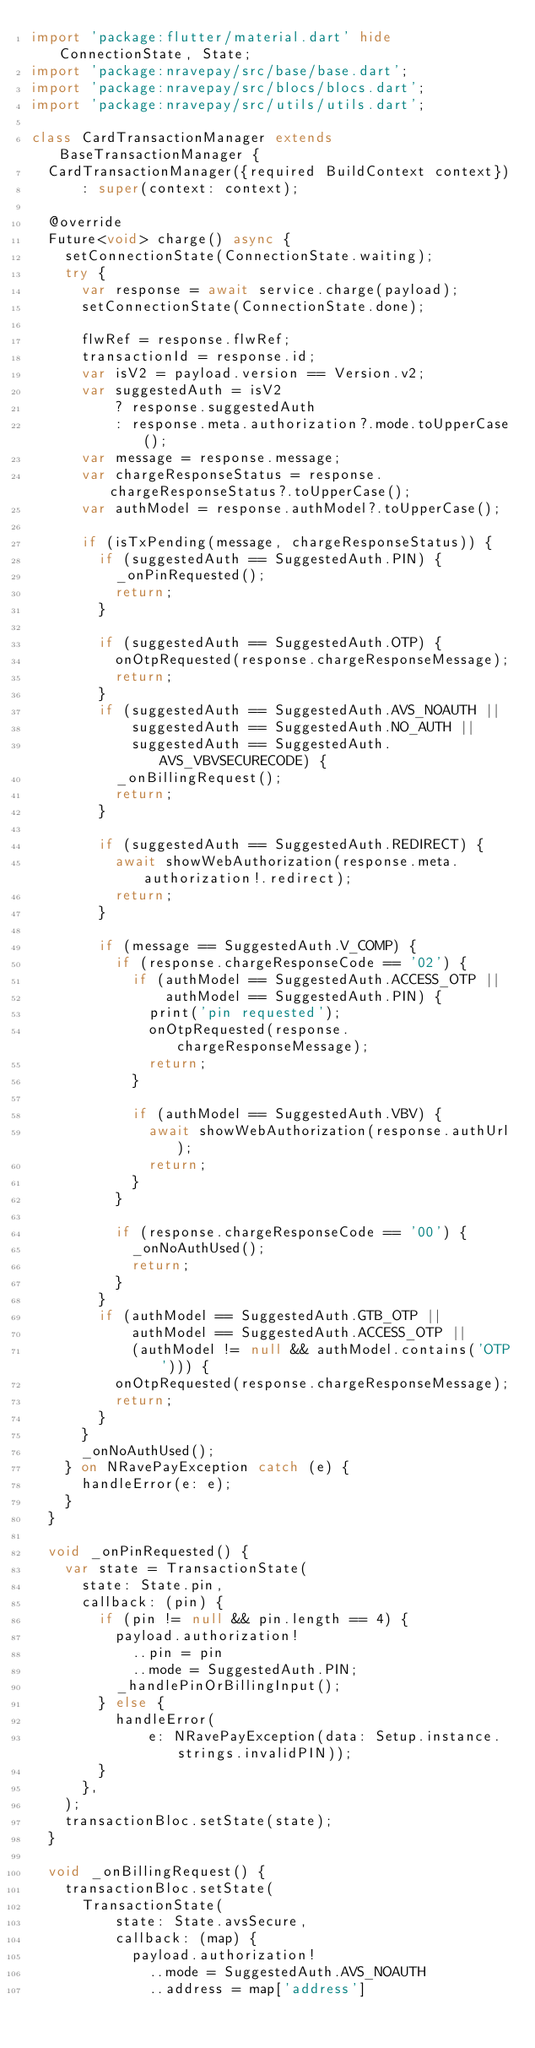<code> <loc_0><loc_0><loc_500><loc_500><_Dart_>import 'package:flutter/material.dart' hide ConnectionState, State;
import 'package:nravepay/src/base/base.dart';
import 'package:nravepay/src/blocs/blocs.dart';
import 'package:nravepay/src/utils/utils.dart';

class CardTransactionManager extends BaseTransactionManager {
  CardTransactionManager({required BuildContext context})
      : super(context: context);

  @override
  Future<void> charge() async {
    setConnectionState(ConnectionState.waiting);
    try {
      var response = await service.charge(payload);
      setConnectionState(ConnectionState.done);

      flwRef = response.flwRef;
      transactionId = response.id;
      var isV2 = payload.version == Version.v2;
      var suggestedAuth = isV2
          ? response.suggestedAuth
          : response.meta.authorization?.mode.toUpperCase();
      var message = response.message;
      var chargeResponseStatus = response.chargeResponseStatus?.toUpperCase();
      var authModel = response.authModel?.toUpperCase();

      if (isTxPending(message, chargeResponseStatus)) {
        if (suggestedAuth == SuggestedAuth.PIN) {
          _onPinRequested();
          return;
        }

        if (suggestedAuth == SuggestedAuth.OTP) {
          onOtpRequested(response.chargeResponseMessage);
          return;
        }
        if (suggestedAuth == SuggestedAuth.AVS_NOAUTH ||
            suggestedAuth == SuggestedAuth.NO_AUTH ||
            suggestedAuth == SuggestedAuth.AVS_VBVSECURECODE) {
          _onBillingRequest();
          return;
        }

        if (suggestedAuth == SuggestedAuth.REDIRECT) {
          await showWebAuthorization(response.meta.authorization!.redirect);
          return;
        }

        if (message == SuggestedAuth.V_COMP) {
          if (response.chargeResponseCode == '02') {
            if (authModel == SuggestedAuth.ACCESS_OTP ||
                authModel == SuggestedAuth.PIN) {
              print('pin requested');
              onOtpRequested(response.chargeResponseMessage);
              return;
            }

            if (authModel == SuggestedAuth.VBV) {
              await showWebAuthorization(response.authUrl);
              return;
            }
          }

          if (response.chargeResponseCode == '00') {
            _onNoAuthUsed();
            return;
          }
        }
        if (authModel == SuggestedAuth.GTB_OTP ||
            authModel == SuggestedAuth.ACCESS_OTP ||
            (authModel != null && authModel.contains('OTP'))) {
          onOtpRequested(response.chargeResponseMessage);
          return;
        }
      }
      _onNoAuthUsed();
    } on NRavePayException catch (e) {
      handleError(e: e);
    }
  }

  void _onPinRequested() {
    var state = TransactionState(
      state: State.pin,
      callback: (pin) {
        if (pin != null && pin.length == 4) {
          payload.authorization!
            ..pin = pin
            ..mode = SuggestedAuth.PIN;
          _handlePinOrBillingInput();
        } else {
          handleError(
              e: NRavePayException(data: Setup.instance.strings.invalidPIN));
        }
      },
    );
    transactionBloc.setState(state);
  }

  void _onBillingRequest() {
    transactionBloc.setState(
      TransactionState(
          state: State.avsSecure,
          callback: (map) {
            payload.authorization!
              ..mode = SuggestedAuth.AVS_NOAUTH
              ..address = map['address']</code> 